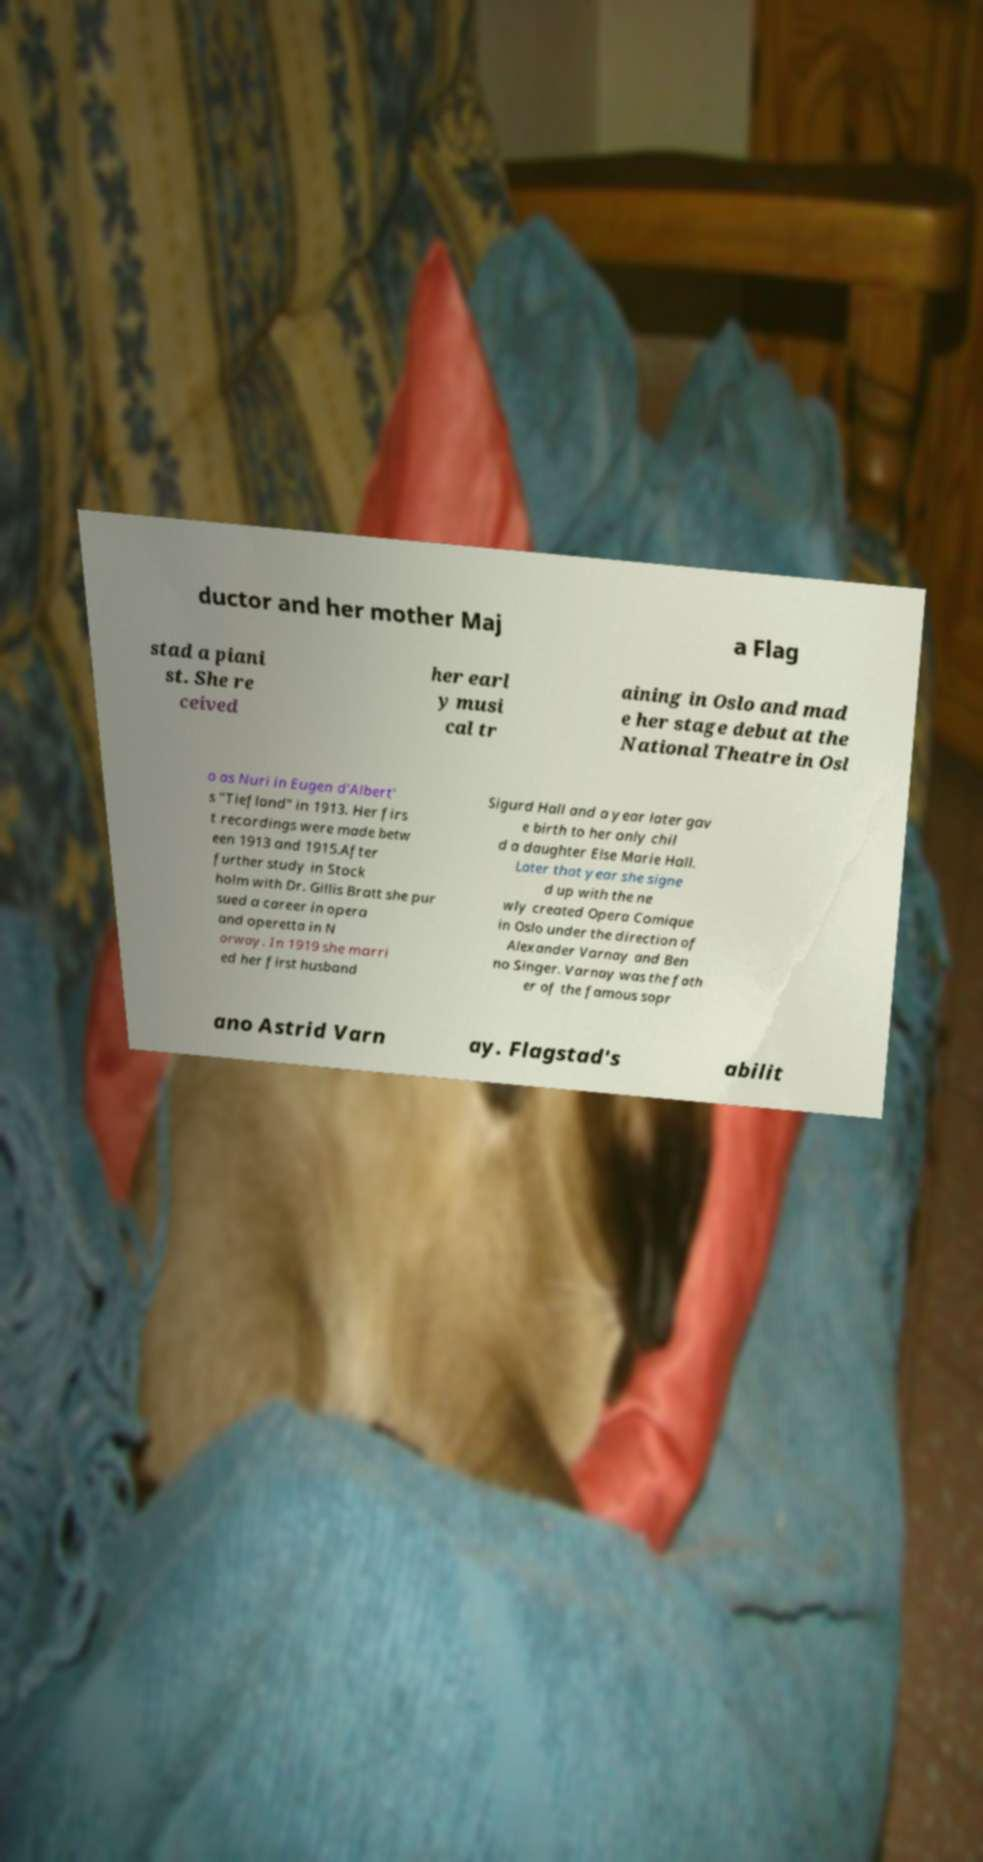For documentation purposes, I need the text within this image transcribed. Could you provide that? ductor and her mother Maj a Flag stad a piani st. She re ceived her earl y musi cal tr aining in Oslo and mad e her stage debut at the National Theatre in Osl o as Nuri in Eugen d'Albert' s "Tiefland" in 1913. Her firs t recordings were made betw een 1913 and 1915.After further study in Stock holm with Dr. Gillis Bratt she pur sued a career in opera and operetta in N orway. In 1919 she marri ed her first husband Sigurd Hall and a year later gav e birth to her only chil d a daughter Else Marie Hall. Later that year she signe d up with the ne wly created Opera Comique in Oslo under the direction of Alexander Varnay and Ben no Singer. Varnay was the fath er of the famous sopr ano Astrid Varn ay. Flagstad's abilit 